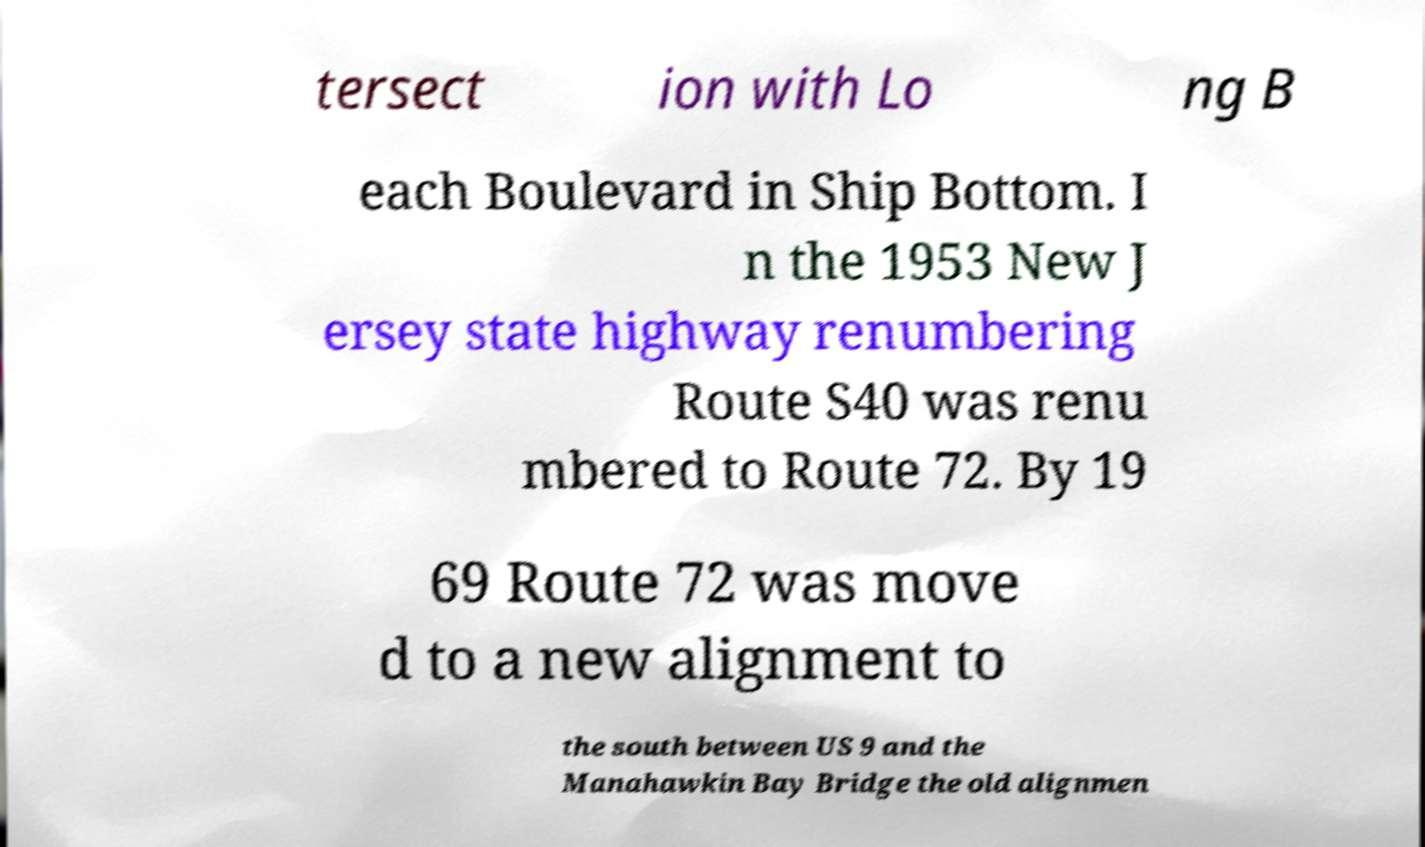Please identify and transcribe the text found in this image. tersect ion with Lo ng B each Boulevard in Ship Bottom. I n the 1953 New J ersey state highway renumbering Route S40 was renu mbered to Route 72. By 19 69 Route 72 was move d to a new alignment to the south between US 9 and the Manahawkin Bay Bridge the old alignmen 